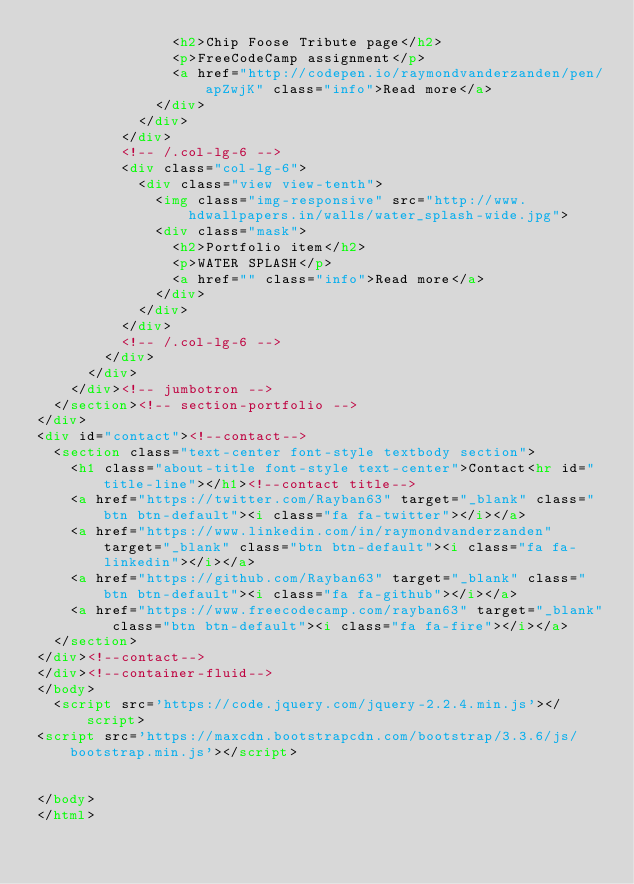Convert code to text. <code><loc_0><loc_0><loc_500><loc_500><_HTML_>                <h2>Chip Foose Tribute page</h2>
                <p>FreeCodeCamp assignment</p>
                <a href="http://codepen.io/raymondvanderzanden/pen/apZwjK" class="info">Read more</a>
              </div>
            </div>
          </div>
          <!-- /.col-lg-6 -->
          <div class="col-lg-6">
            <div class="view view-tenth">
              <img class="img-responsive" src="http://www.hdwallpapers.in/walls/water_splash-wide.jpg">
              <div class="mask">
                <h2>Portfolio item</h2>
                <p>WATER SPLASH</p>
                <a href="" class="info">Read more</a>
              </div>
            </div>
          </div>
          <!-- /.col-lg-6 -->
        </div>
      </div>
    </div><!-- jumbotron -->
  </section><!-- section-portfolio -->
</div>
<div id="contact"><!--contact-->
  <section class="text-center font-style textbody section">
    <h1 class="about-title font-style text-center">Contact<hr id="title-line"></h1><!--contact title-->
    <a href="https://twitter.com/Rayban63" target="_blank" class="btn btn-default"><i class="fa fa-twitter"></i></a>
    <a href="https://www.linkedin.com/in/raymondvanderzanden" target="_blank" class="btn btn-default"><i class="fa fa-linkedin"></i></a>
    <a href="https://github.com/Rayban63" target="_blank" class="btn btn-default"><i class="fa fa-github"></i></a>
    <a href="https://www.freecodecamp.com/rayban63" target="_blank" class="btn btn-default"><i class="fa fa-fire"></i></a>
  </section>
</div><!--contact-->
</div><!--container-fluid-->
</body>
  <script src='https://code.jquery.com/jquery-2.2.4.min.js'></script>
<script src='https://maxcdn.bootstrapcdn.com/bootstrap/3.3.6/js/bootstrap.min.js'></script>

  
</body>
</html>
</code> 